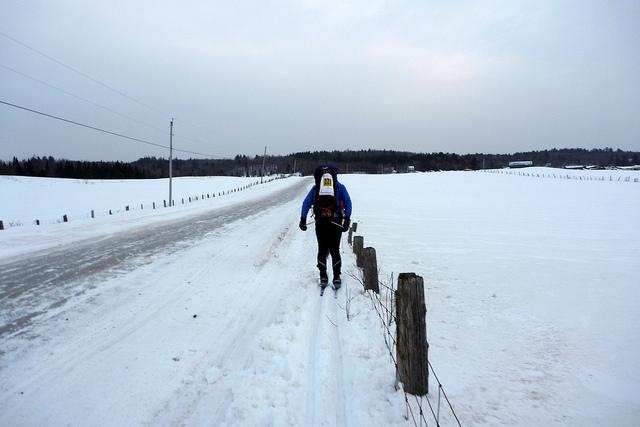What's on the skier's back?
Be succinct. Backpack. What number of poles line this road?
Answer briefly. 50. Would a bikini be appropriate for this sport?
Be succinct. No. 